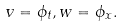<formula> <loc_0><loc_0><loc_500><loc_500>v = \phi _ { t } , w = \phi _ { x } .</formula> 